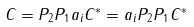Convert formula to latex. <formula><loc_0><loc_0><loc_500><loc_500>C = P _ { 2 } P _ { 1 } a _ { i } C ^ { * } = a _ { i } P _ { 2 } P _ { 1 } C ^ { * }</formula> 